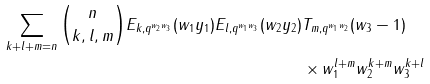Convert formula to latex. <formula><loc_0><loc_0><loc_500><loc_500>\sum _ { k + l + m = n } \binom { n } { k , l , m } E _ { k , q ^ { w _ { 2 } w _ { 3 } } } ( w _ { 1 } y _ { 1 } ) E _ { l , q ^ { w _ { 1 } w _ { 3 } } } ( w _ { 2 } y _ { 2 } ) & T _ { m , q ^ { w _ { 1 } w _ { 2 } } } ( w _ { 3 } - 1 ) \\ & \times w _ { 1 } ^ { l + m } w _ { 2 } ^ { k + m } w _ { 3 } ^ { k + l }</formula> 